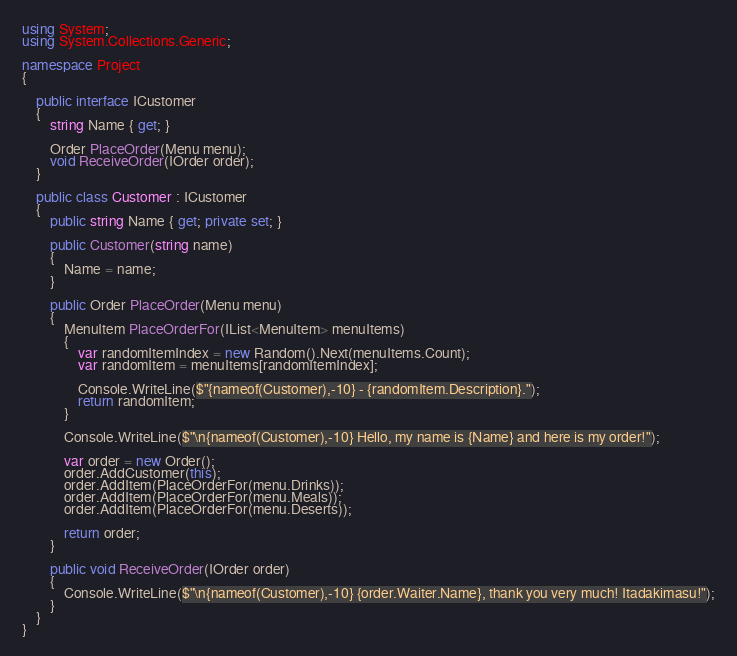Convert code to text. <code><loc_0><loc_0><loc_500><loc_500><_C#_>using System;
using System.Collections.Generic;

namespace Project
{

    public interface ICustomer
    {
        string Name { get; }

        Order PlaceOrder(Menu menu);
        void ReceiveOrder(IOrder order);
    }

    public class Customer : ICustomer
    {
        public string Name { get; private set; }

        public Customer(string name)
        {
            Name = name;
        }

        public Order PlaceOrder(Menu menu)
        {
            MenuItem PlaceOrderFor(IList<MenuItem> menuItems)
            {
                var randomItemIndex = new Random().Next(menuItems.Count);
                var randomItem = menuItems[randomItemIndex];

                Console.WriteLine($"{nameof(Customer),-10} - {randomItem.Description}.");
                return randomItem;
            }

            Console.WriteLine($"\n{nameof(Customer),-10} Hello, my name is {Name} and here is my order!");

            var order = new Order();
            order.AddCustomer(this);
            order.AddItem(PlaceOrderFor(menu.Drinks));
            order.AddItem(PlaceOrderFor(menu.Meals));
            order.AddItem(PlaceOrderFor(menu.Deserts));

            return order;
        }

        public void ReceiveOrder(IOrder order)
        {
            Console.WriteLine($"\n{nameof(Customer),-10} {order.Waiter.Name}, thank you very much! Itadakimasu!");
        }
    }
}
</code> 